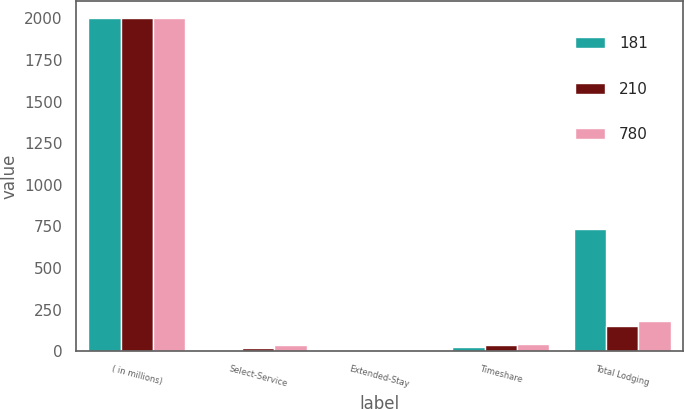Convert chart to OTSL. <chart><loc_0><loc_0><loc_500><loc_500><stacked_bar_chart><ecel><fcel>( in millions)<fcel>Select-Service<fcel>Extended-Stay<fcel>Timeshare<fcel>Total Lodging<nl><fcel>181<fcel>2005<fcel>4<fcel>6<fcel>27<fcel>734<nl><fcel>210<fcel>2004<fcel>16<fcel>1<fcel>38<fcel>150<nl><fcel>780<fcel>2003<fcel>38<fcel>3<fcel>45<fcel>179<nl></chart> 